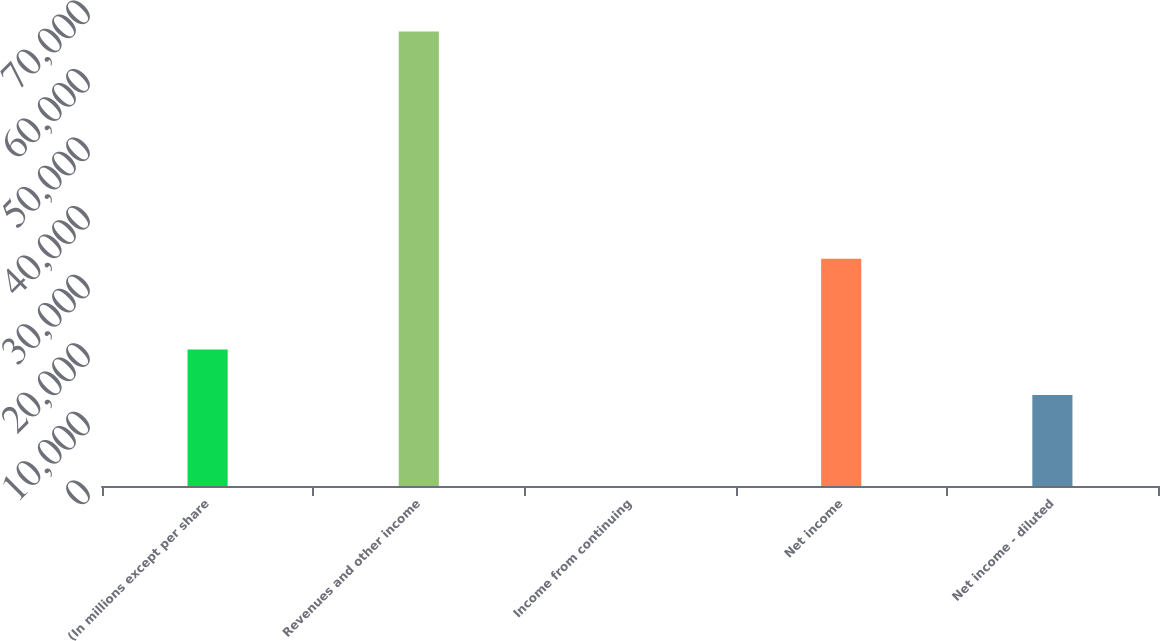Convert chart. <chart><loc_0><loc_0><loc_500><loc_500><bar_chart><fcel>(In millions except per share<fcel>Revenues and other income<fcel>Income from continuing<fcel>Net income<fcel>Net income - diluted<nl><fcel>19889.3<fcel>66283<fcel>6.3<fcel>33144.7<fcel>13261.6<nl></chart> 